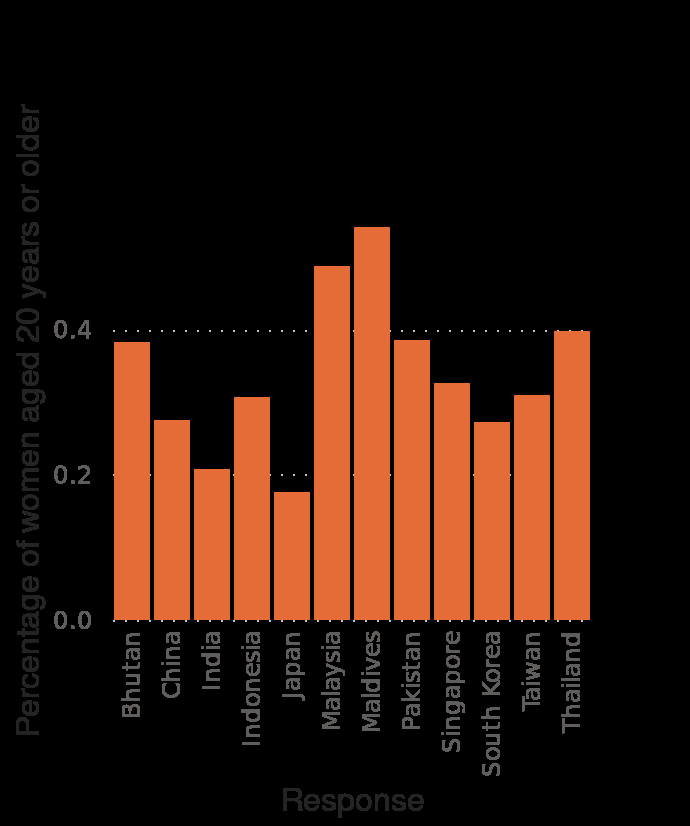<image>
What country in Asia had the highest overweight and obesity rates among female adults?  The Maldives had the highest overweight and obesity rates amongst female adults in Asia. Describe the following image in detail Overweight and obesity rates among female adults in selected Asian countries as of 2013 is a bar chart. The y-axis measures Percentage of women aged 20 years or older while the x-axis shows Response. 